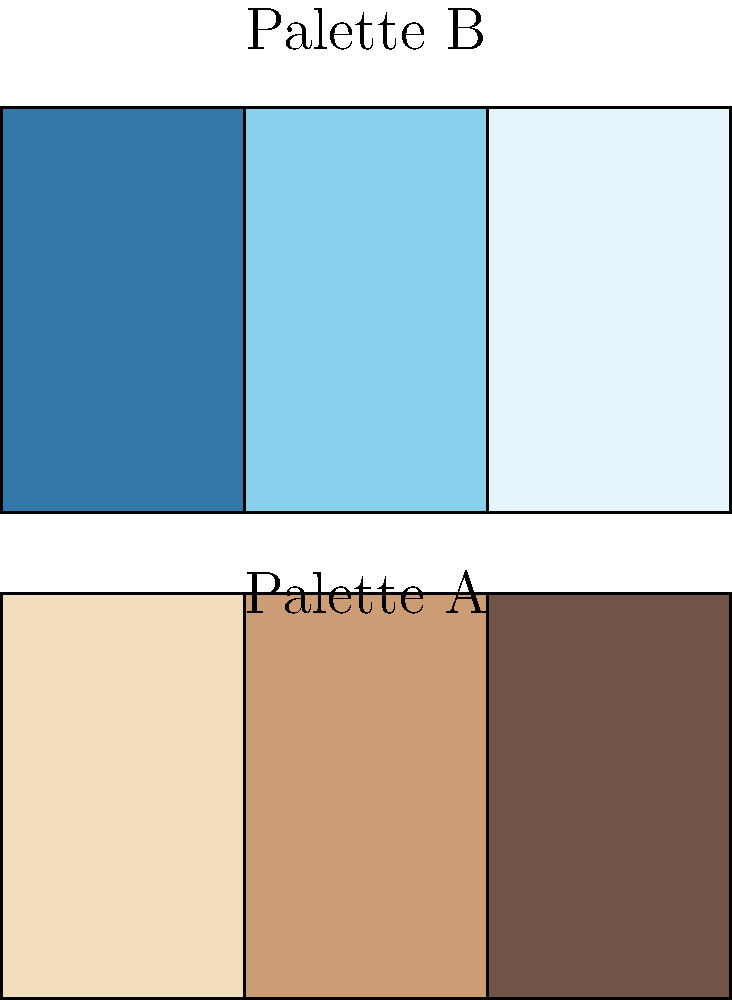In "Back to the Future", which color palette more closely represents the visual style used for scenes set in 1955, and what might this choice symbolize about the film's themes? To answer this question, we need to analyze the color palettes and their potential symbolism in relation to "Back to the Future":

1. Palette A: This palette consists of warm, muted tones (beige, tan, and brown). These colors are often associated with:
   - Nostalgia and vintage aesthetics
   - Sepia-toned photographs
   - A sense of the past or memory

2. Palette B: This palette features cool, vibrant blues. These colors typically represent:
   - Modernity and technology
   - The future or forward-thinking
   - Clarity and coolness

3. In "Back to the Future", the scenes set in 1955 are deliberately styled to evoke a sense of nostalgia and the past. The filmmakers would likely use warmer, more muted tones to achieve this effect.

4. Palette A more closely aligns with this aesthetic goal. The warm, slightly faded look of these colors would help create a visual distinction between the past (1955) and the present/future (1985) in the film.

5. Symbolically, this color choice reinforces the film's themes of:
   - Contrast between past and present
   - The rose-tinted view of the past (warm colors)
   - The idea of memory and how we perceive history

6. By using this palette for 1955 scenes, the filmmakers create a visual metaphor for Marty's journey through time, emphasizing the "pastness" of the 1955 setting and enhancing the fish-out-of-water element of his adventure.

Therefore, Palette A is more representative of the 1955 scenes in "Back to the Future", symbolizing nostalgia, the past, and the film's exploration of time and memory.
Answer: Palette A, symbolizing nostalgia and the past 